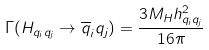<formula> <loc_0><loc_0><loc_500><loc_500>\Gamma ( H _ { q _ { i } q _ { j } } \rightarrow \overline { q } _ { i } q _ { j } ) = \frac { 3 M _ { H } h _ { q _ { i } q _ { j } } ^ { 2 } } { 1 6 \pi }</formula> 